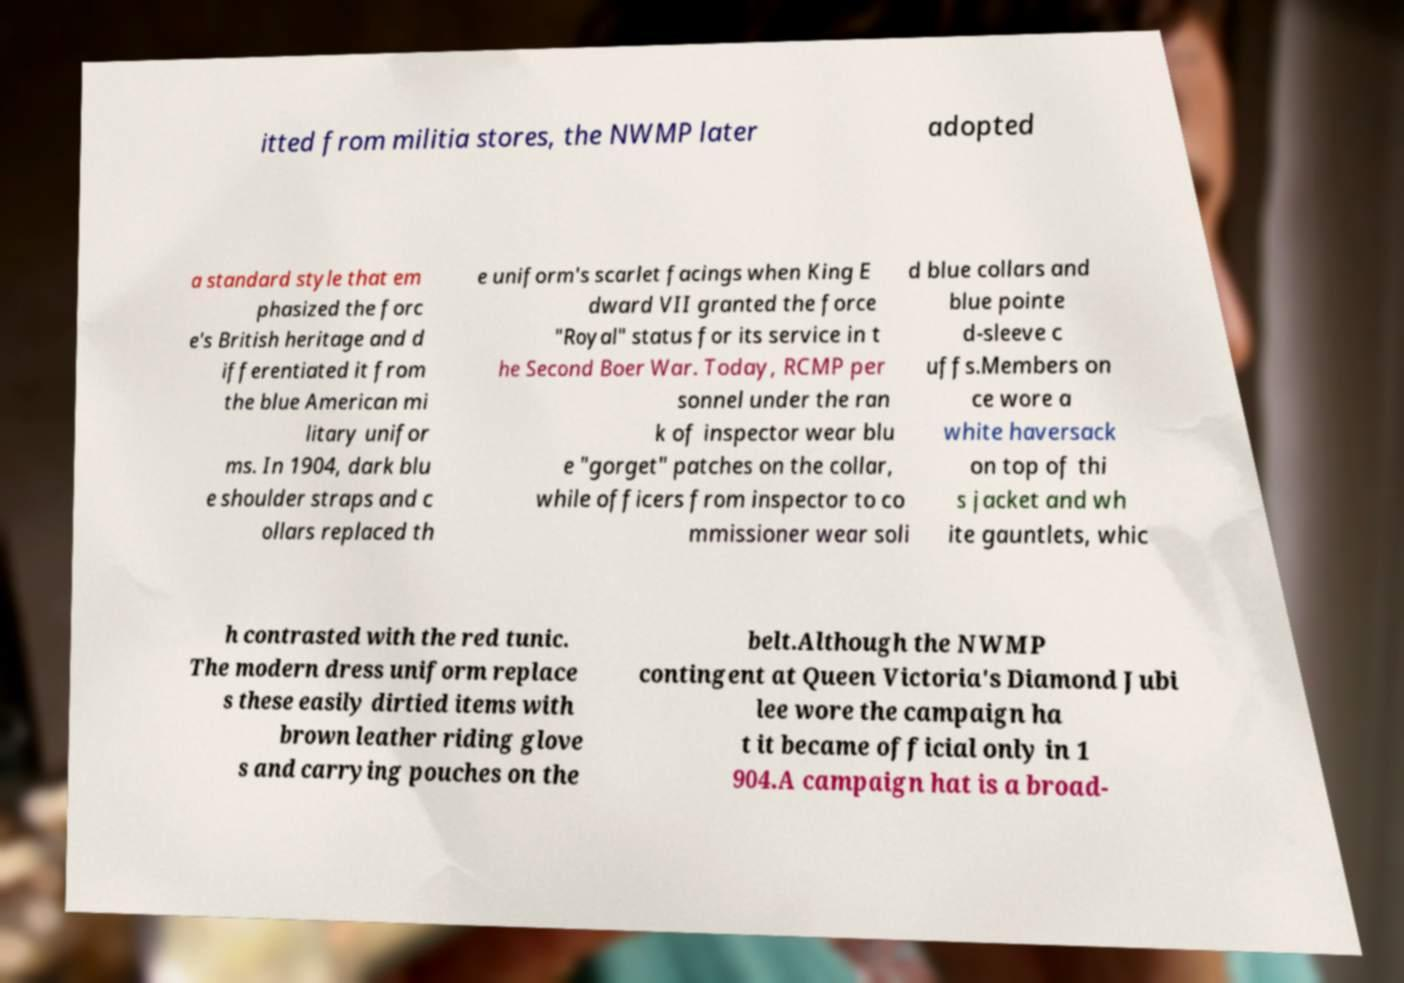Could you extract and type out the text from this image? itted from militia stores, the NWMP later adopted a standard style that em phasized the forc e's British heritage and d ifferentiated it from the blue American mi litary unifor ms. In 1904, dark blu e shoulder straps and c ollars replaced th e uniform's scarlet facings when King E dward VII granted the force "Royal" status for its service in t he Second Boer War. Today, RCMP per sonnel under the ran k of inspector wear blu e "gorget" patches on the collar, while officers from inspector to co mmissioner wear soli d blue collars and blue pointe d-sleeve c uffs.Members on ce wore a white haversack on top of thi s jacket and wh ite gauntlets, whic h contrasted with the red tunic. The modern dress uniform replace s these easily dirtied items with brown leather riding glove s and carrying pouches on the belt.Although the NWMP contingent at Queen Victoria's Diamond Jubi lee wore the campaign ha t it became official only in 1 904.A campaign hat is a broad- 